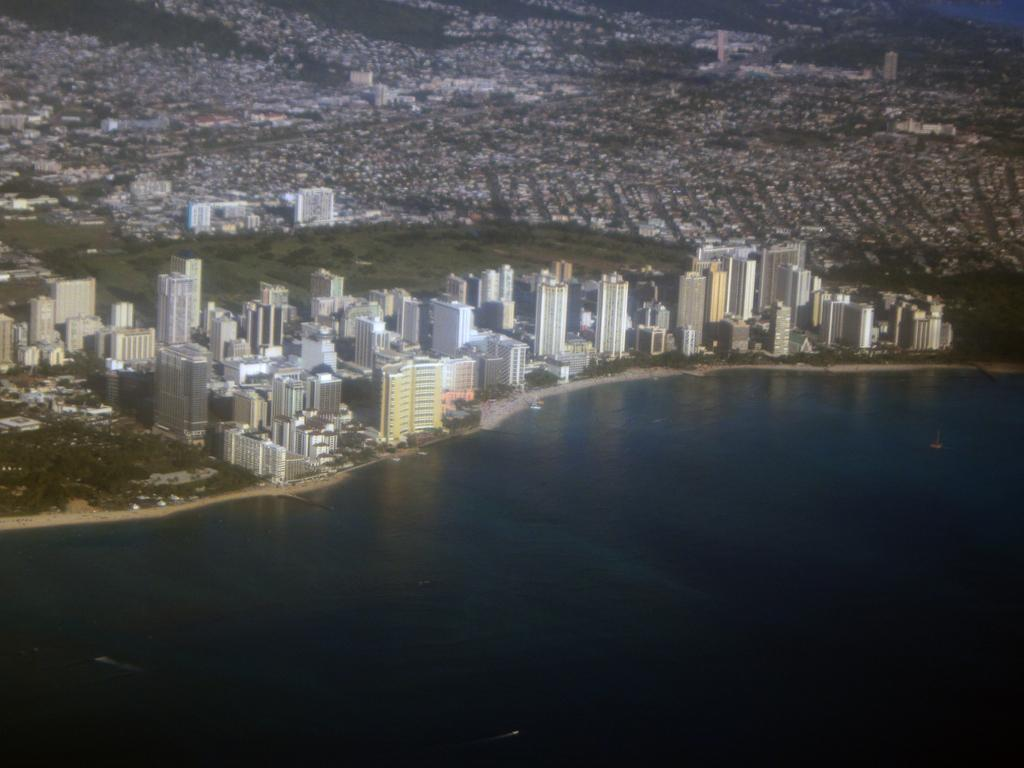What is the main subject of the image? The image provides an overview of a city. Can you describe any natural features visible in the image? The sea is present at the bottom of the image. How many friends are visible in the image? There are no friends present in the image; it provides an overview of a city and shows the sea at the bottom. 